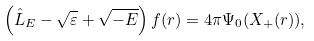<formula> <loc_0><loc_0><loc_500><loc_500>\left ( \hat { L } _ { E } - \sqrt { \varepsilon } + \sqrt { - E } \right ) f ( { r } ) = 4 \pi \Psi _ { 0 } ( X _ { + } ( { r } ) ) ,</formula> 